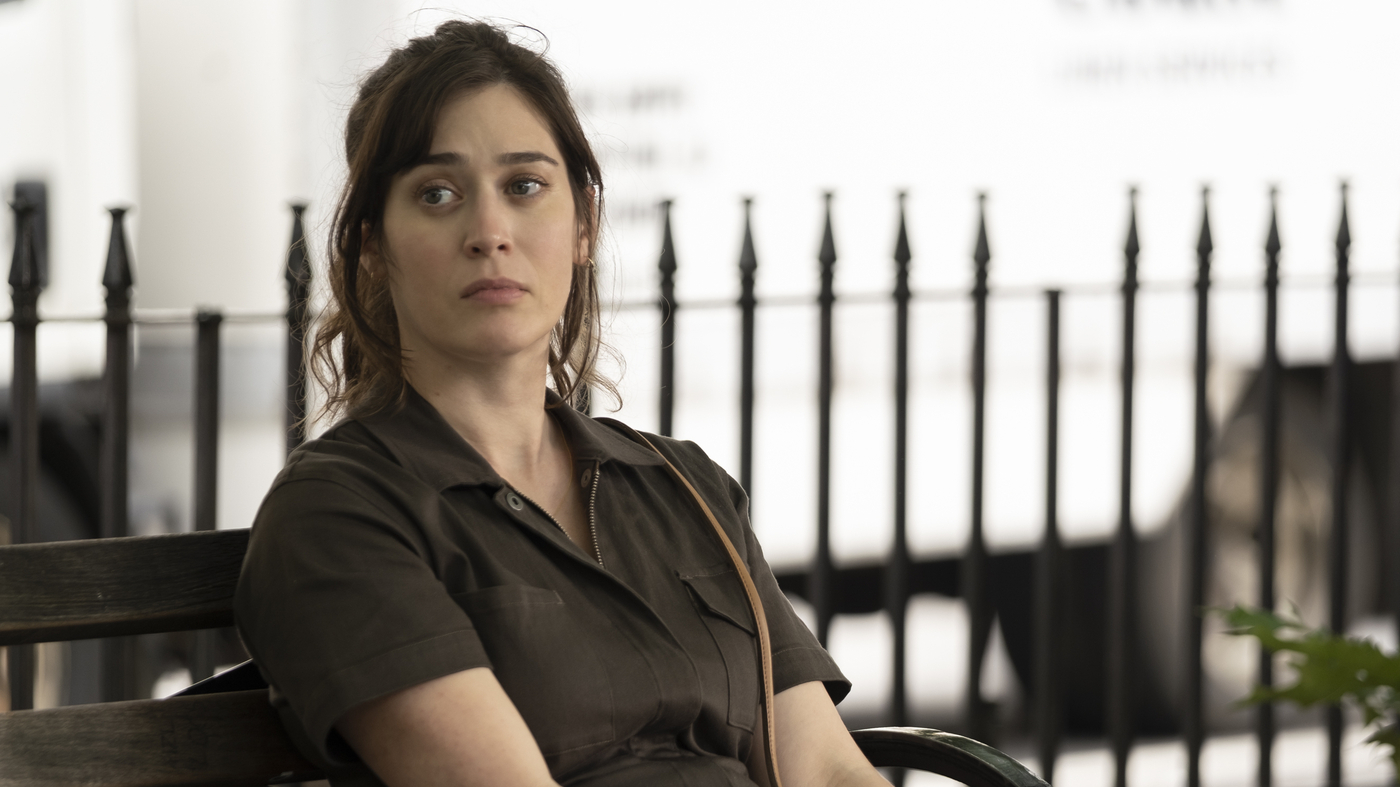Describe the architecture visible behind the woman. The architecture behind the woman features a white background with a classic design. The presence of black railings adds a traditional touch, likely indicative of a well-maintained urban park or a similar public area. The building's simple yet elegant façade complements the tranquil atmosphere of the setting. 